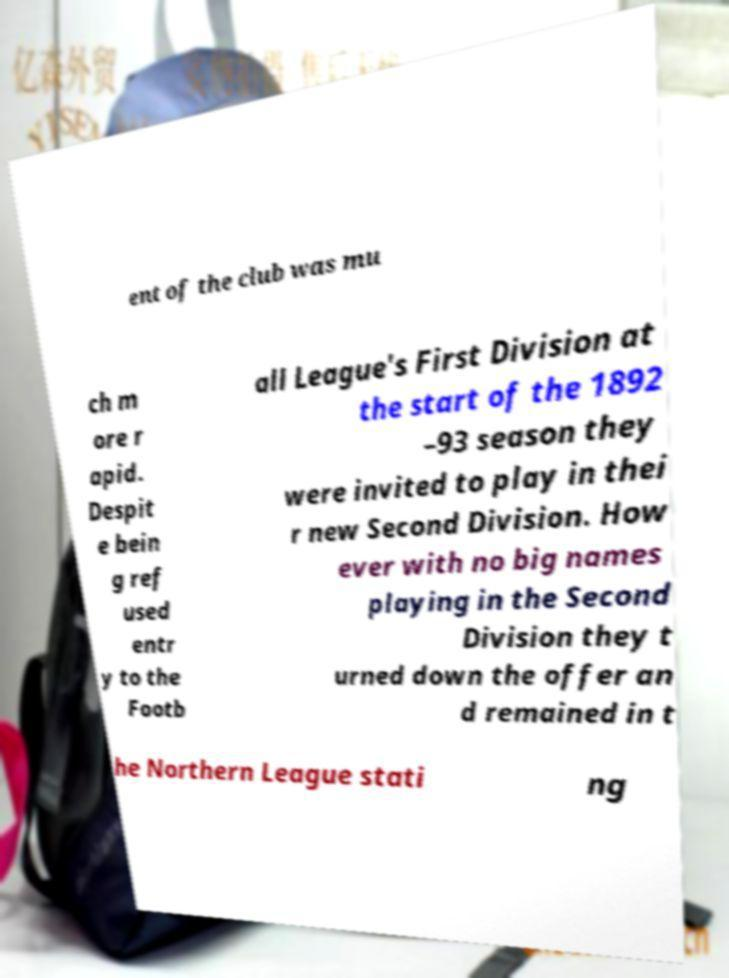Can you read and provide the text displayed in the image?This photo seems to have some interesting text. Can you extract and type it out for me? ent of the club was mu ch m ore r apid. Despit e bein g ref used entr y to the Footb all League's First Division at the start of the 1892 –93 season they were invited to play in thei r new Second Division. How ever with no big names playing in the Second Division they t urned down the offer an d remained in t he Northern League stati ng 